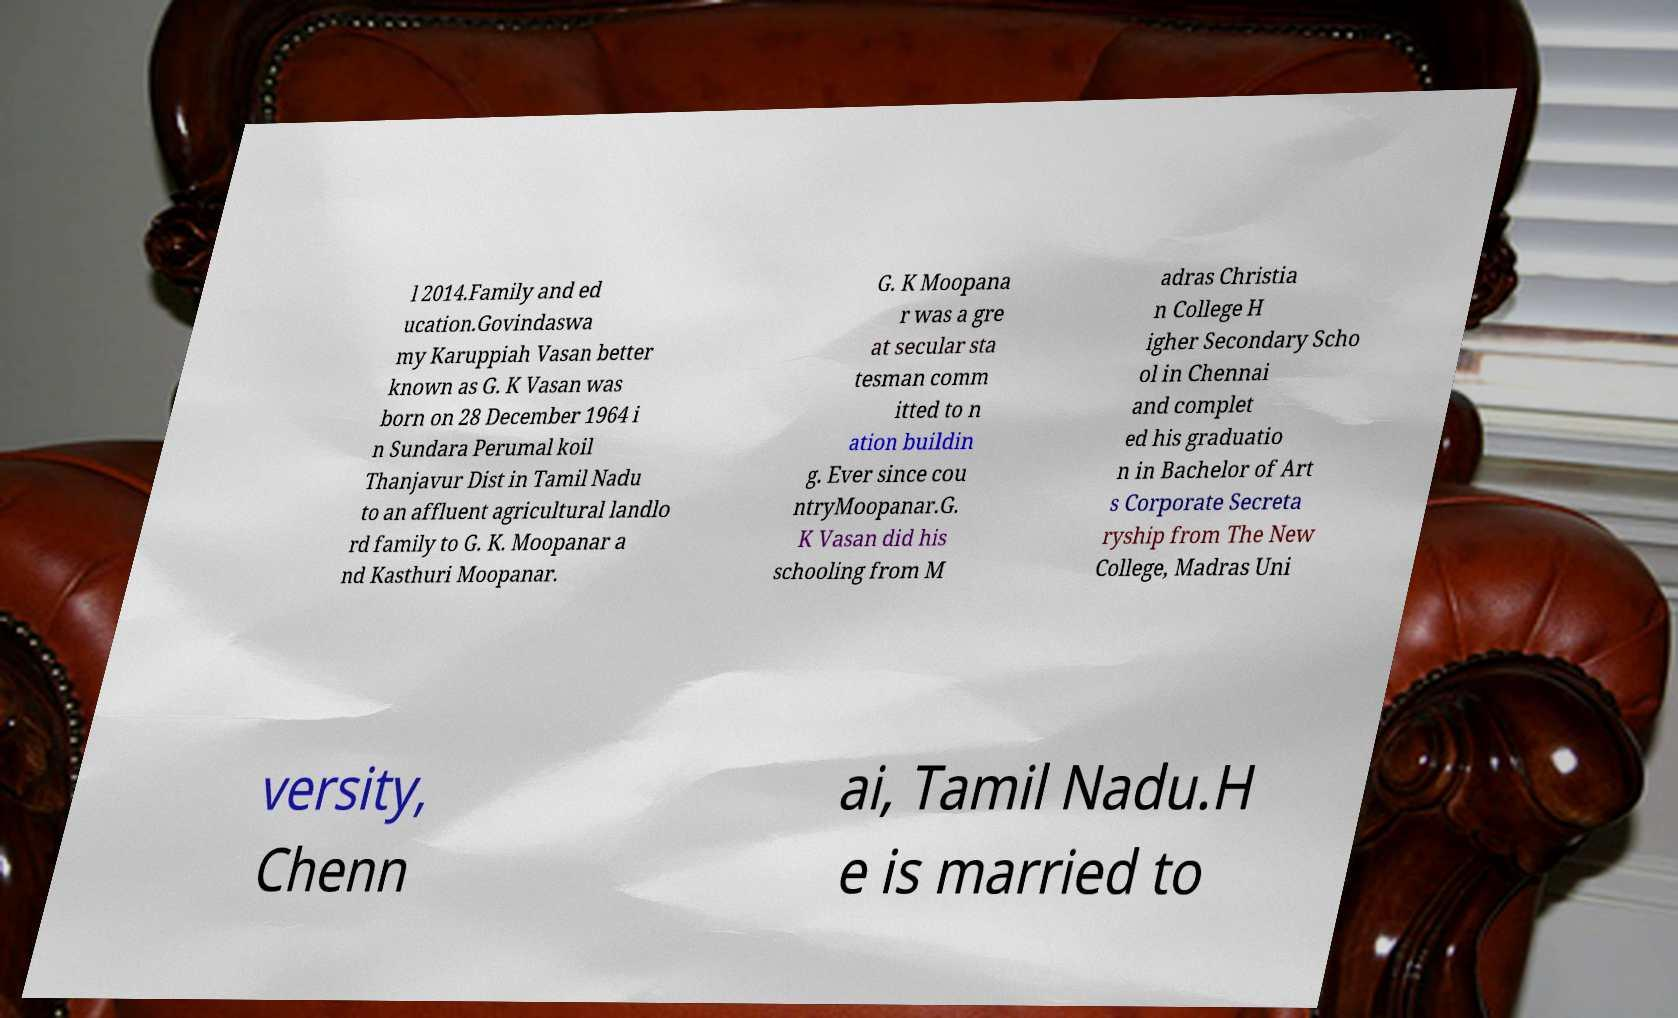What messages or text are displayed in this image? I need them in a readable, typed format. l 2014.Family and ed ucation.Govindaswa my Karuppiah Vasan better known as G. K Vasan was born on 28 December 1964 i n Sundara Perumal koil Thanjavur Dist in Tamil Nadu to an affluent agricultural landlo rd family to G. K. Moopanar a nd Kasthuri Moopanar. G. K Moopana r was a gre at secular sta tesman comm itted to n ation buildin g. Ever since cou ntryMoopanar.G. K Vasan did his schooling from M adras Christia n College H igher Secondary Scho ol in Chennai and complet ed his graduatio n in Bachelor of Art s Corporate Secreta ryship from The New College, Madras Uni versity, Chenn ai, Tamil Nadu.H e is married to 